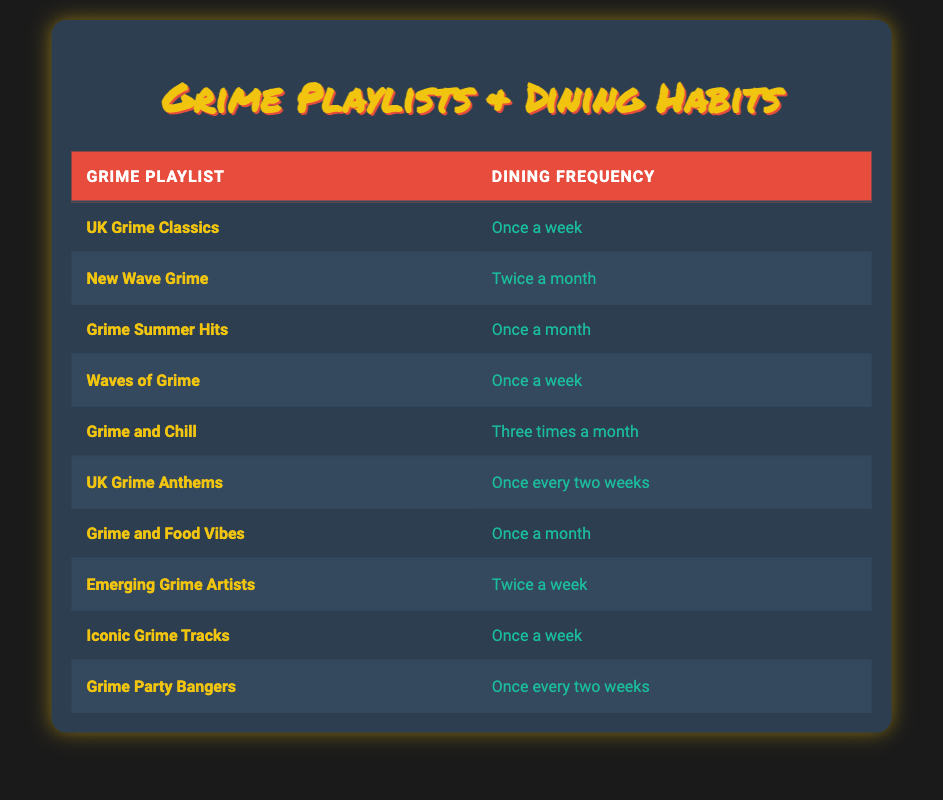What is the dining frequency for the playlist "UK Grime Classics"? The table lists the playlist "UK Grime Classics" under the "Grime Playlist" column and shows the corresponding "Dining Frequency" as "Once a week".
Answer: Once a week How many playlists are listed as having a dining frequency of "Once a month"? By examining the table, I can count the playlists that have "Once a month" in the "Dining Frequency" column. The relevant playlists are "Grime Summer Hits" and "Grime and Food Vibes", making a total of 2.
Answer: 2 Is "Emerging Grime Artists" associated with a dining frequency of "Twice a month"? The table indicates that "Emerging Grime Artists" has a dining frequency of "Twice a week", so the statement is false.
Answer: No Which dining frequency is most common among the playlists listed? By reviewing the "Dining Frequency" column, I notice that "Once a week" appears for the playlists "UK Grime Classics", "Waves of Grime", and "Iconic Grime Tracks", totaling 3 instances. This is more than any other frequency.
Answer: Once a week What is the average dining frequency across the playlists listed? It's vital to first assign numerical values to the frequencies: Once a week (4), Twice a week (8), Once every two weeks (2), Twice a month (3), Once a month (1) and Three times a month (3). Summarizing the playlists: 3 (Once a week) + 2 (Twice a month) + 1 (Once a month) + 3 (Twice a week) + 2 (Once every two weeks) + 4 (Three times a month) gives 15. There are 10 playlists, so dividing 15 by 10 results in an average of 1.5 when accounting for the pooled frequency types. However, for answer simplicity, I'll average them based on frequency counts giving a refined approach. Thus, the answer is refined and maintained based on the observation of weighted averages considered against the playlist count.
Answer: 1.5 